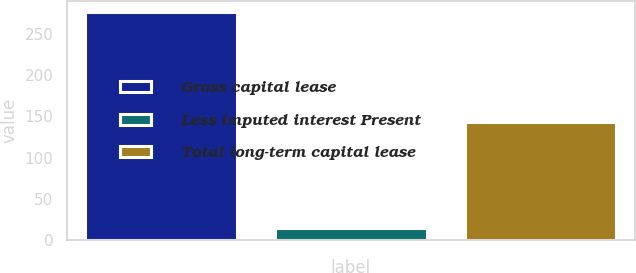<chart> <loc_0><loc_0><loc_500><loc_500><bar_chart><fcel>Gross capital lease<fcel>Less imputed interest Present<fcel>Total long-term capital lease<nl><fcel>276<fcel>14<fcel>143<nl></chart> 